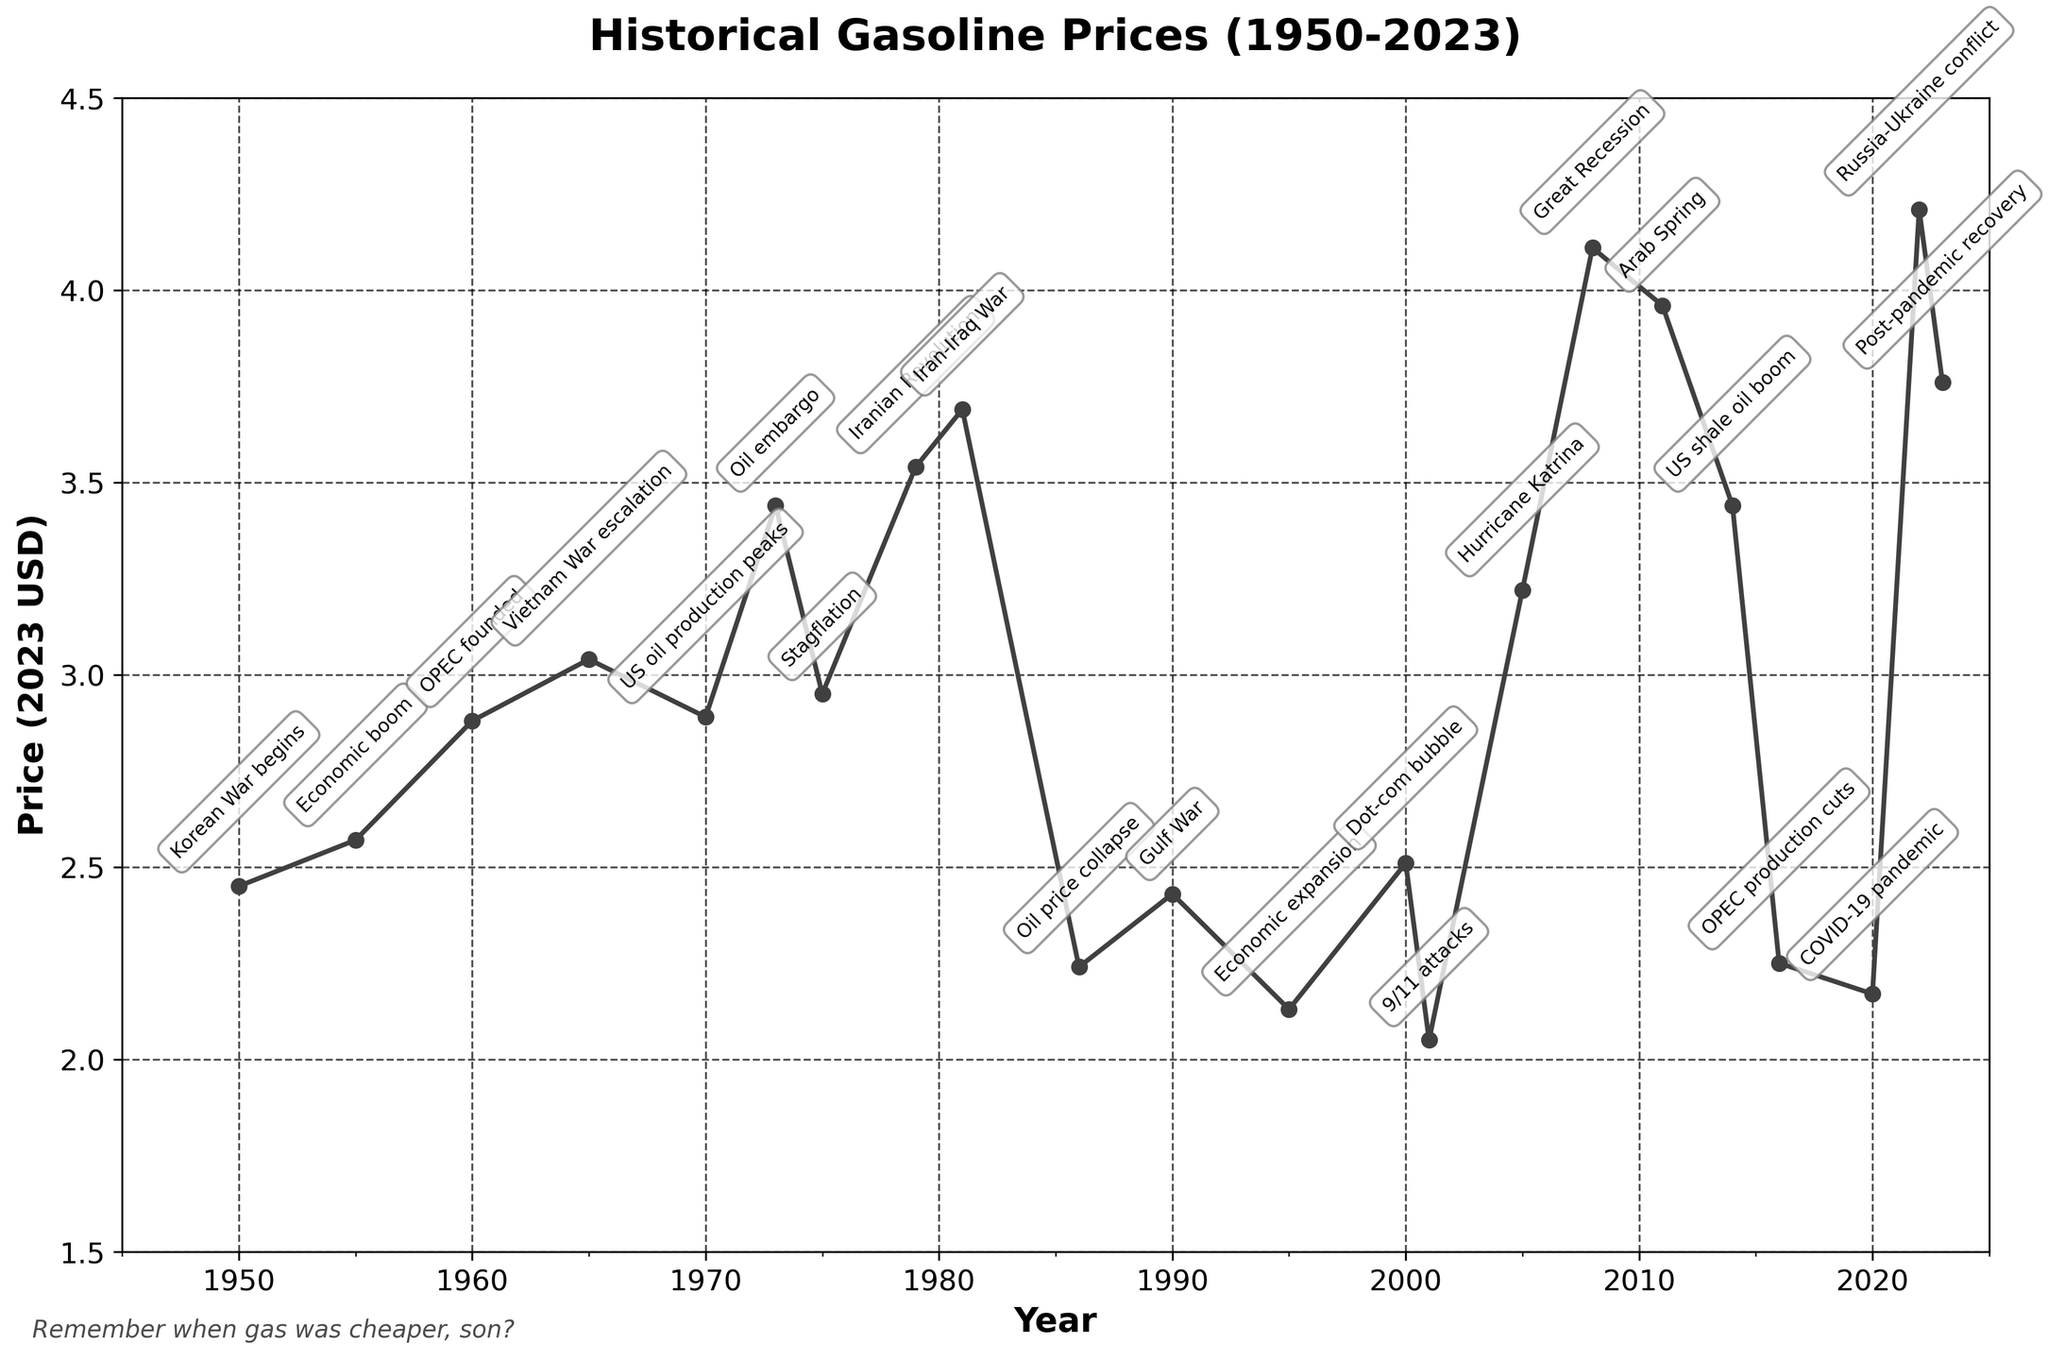What is the highest gasoline price shown on the chart? The highest value on the y-axis represents gasoline price in 2023 USD. The peak is at $4.21 in 2022, corresponding with the Russia-Ukraine conflict event label.
Answer: $4.21 When was the last time gasoline prices peaked before the post-pandemic recovery in 2023? Observing the chart, the previous peak before 2023 is in 2014 during the US shale oil boom, where the price reached $3.44.
Answer: 2014 Which economic event caused the steepest decline in gasoline prices? Looking at the largest drop in the line, the most significant decline occurred after the Oil price collapse in 1986, dropping from $3.69 in 1981 to $2.24.
Answer: Oil price collapse in 1986 During which wars did gasoline prices increase? Analyzing the points marked with war-related events, prices increased during the Korean War, Vietnam War, and Gulf War, particularly in years 1950, 1965, and 1990.
Answer: Korean War, Vietnam War, Gulf War What is the average gasoline price from 2010 to 2020? The prices in this period are: 2011 ($3.96), 2014 ($3.44), 2016 ($2.25), and 2020 ($2.17). The sum is $11.82, divided by 4, resulting in an average of $2.96.
Answer: $2.96 How did gasoline prices react to the 2008 Great Recession and the 2020 COVID-19 pandemic? The chart shows a significant price spike during the Great Recession in 2008 ($4.11) and a notable drop during the COVID-19 pandemic in 2020 ($2.17).
Answer: Significant spike in 2008 and drop in 2020 Which event saw a gasoline price higher than both the US shale oil boom in 2014 and the Dot-com bubble in 2000? Looking at the chart, the Great Recession in 2008 ($4.11) saw a price higher than the US shale oil boom ($3.44) and the Dot-com bubble ($2.51).
Answer: Great Recession in 2008 What has been the general trend in gasoline prices since the 1980s? From a peak in 1981 ($3.69), prices saw fluctuations but overall, a pattern of periodic spikes and drops is visible, correlating with events, trending generally upward to present.
Answer: Periodic spikes and drops, generally upward Compare the gasoline prices during the Iran-Iraq War and the Arab Spring. Which was higher? The figure shows that the gasoline price was higher during the Iran-Iraq War in 1981 ($3.69) compared to the Arab Spring in 2011 ($3.96).
Answer: Arab Spring was higher 